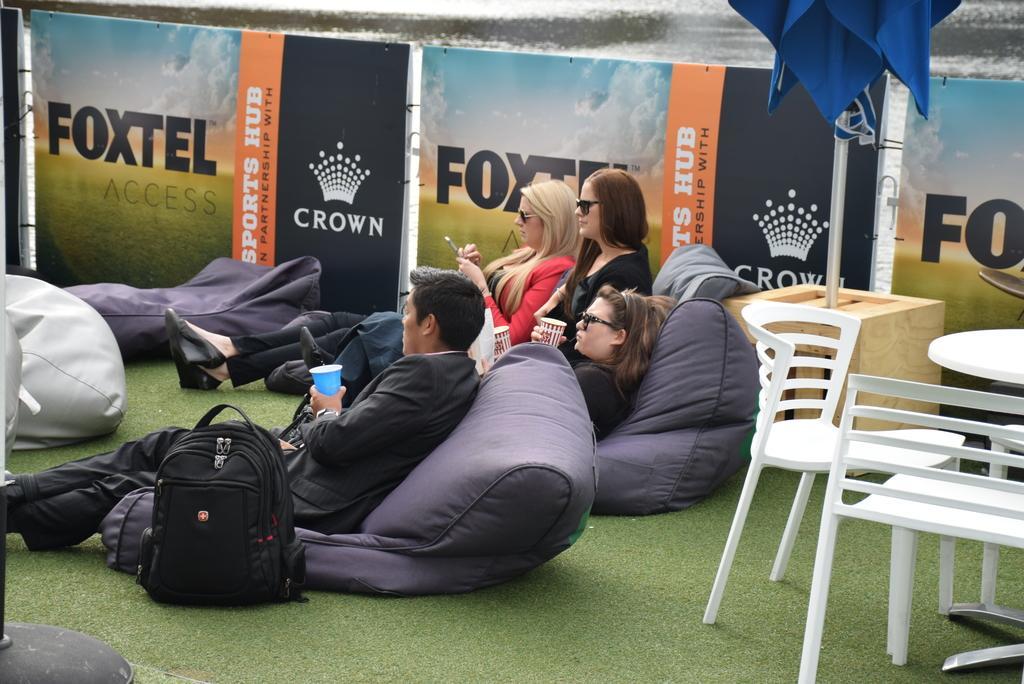In one or two sentences, can you explain what this image depicts? In this image, In the middle there are some people sitting on the black color objects there is a bag which is in black color, In the right side there are some chairs which are in white color, There is a table in white color on that table there is a blue color cloth, In the background there is a poster which is in blue and black color. 